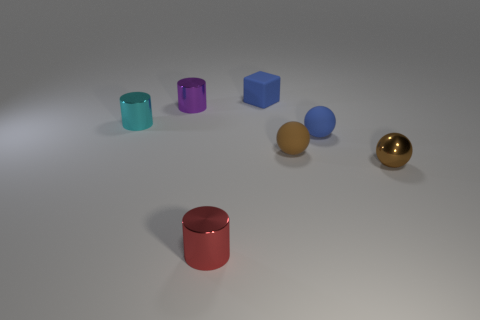There is a purple cylinder that is the same size as the red thing; what material is it?
Offer a terse response. Metal. Is there a object that has the same material as the red cylinder?
Provide a succinct answer. Yes. What number of yellow metallic objects are there?
Your answer should be compact. 0. Do the blue block and the cylinder behind the small cyan metal cylinder have the same material?
Provide a short and direct response. No. What is the material of the other ball that is the same color as the small metallic ball?
Keep it short and to the point. Rubber. How many other shiny spheres are the same color as the tiny shiny ball?
Provide a short and direct response. 0. The red cylinder is what size?
Give a very brief answer. Small. Does the small red shiny thing have the same shape as the metal object to the right of the tiny brown matte object?
Make the answer very short. No. There is a tiny ball that is the same material as the tiny purple cylinder; what color is it?
Provide a succinct answer. Brown. How big is the cylinder that is to the right of the small purple cylinder?
Keep it short and to the point. Small. 